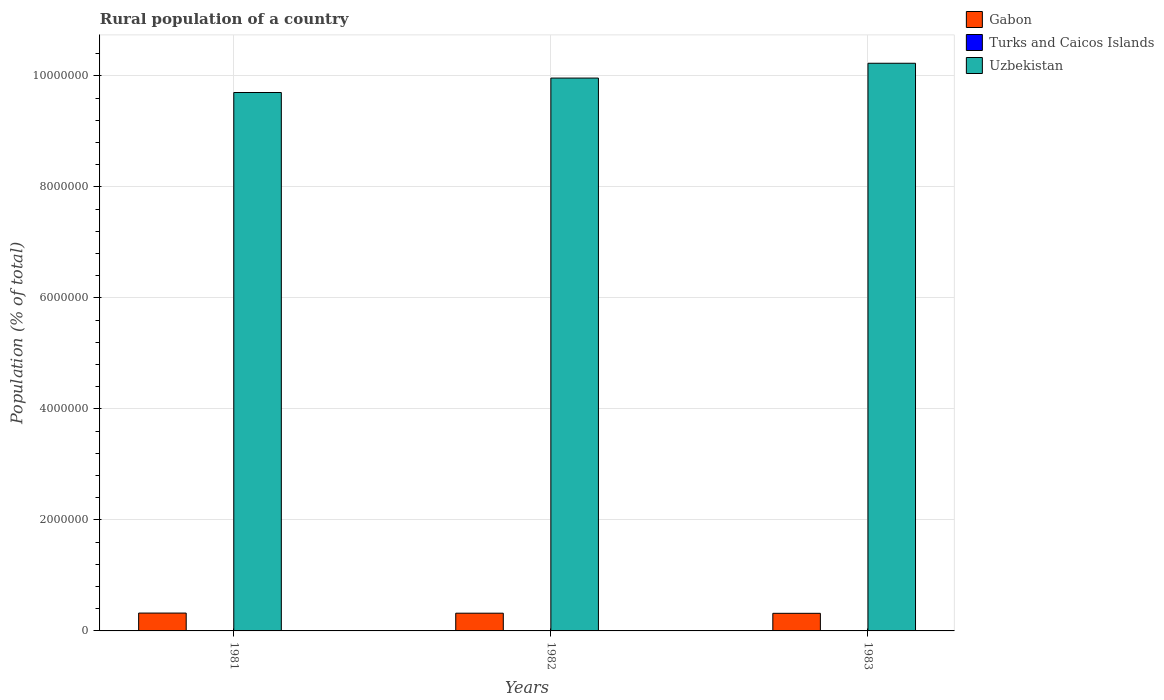How many groups of bars are there?
Offer a terse response. 3. Are the number of bars on each tick of the X-axis equal?
Offer a very short reply. Yes. How many bars are there on the 3rd tick from the right?
Ensure brevity in your answer.  3. What is the rural population in Turks and Caicos Islands in 1981?
Keep it short and to the point. 3350. Across all years, what is the maximum rural population in Uzbekistan?
Keep it short and to the point. 1.02e+07. Across all years, what is the minimum rural population in Gabon?
Make the answer very short. 3.17e+05. What is the total rural population in Gabon in the graph?
Your response must be concise. 9.58e+05. What is the difference between the rural population in Turks and Caicos Islands in 1981 and that in 1982?
Offer a very short reply. 5. What is the difference between the rural population in Uzbekistan in 1982 and the rural population in Gabon in 1983?
Make the answer very short. 9.64e+06. What is the average rural population in Turks and Caicos Islands per year?
Your answer should be very brief. 3345. In the year 1981, what is the difference between the rural population in Turks and Caicos Islands and rural population in Gabon?
Offer a terse response. -3.18e+05. What is the ratio of the rural population in Uzbekistan in 1981 to that in 1982?
Give a very brief answer. 0.97. Is the rural population in Uzbekistan in 1982 less than that in 1983?
Offer a very short reply. Yes. What is the difference between the highest and the second highest rural population in Uzbekistan?
Your answer should be compact. 2.67e+05. What is the difference between the highest and the lowest rural population in Uzbekistan?
Your answer should be very brief. 5.27e+05. What does the 3rd bar from the left in 1983 represents?
Your response must be concise. Uzbekistan. What does the 1st bar from the right in 1981 represents?
Your answer should be compact. Uzbekistan. Is it the case that in every year, the sum of the rural population in Gabon and rural population in Turks and Caicos Islands is greater than the rural population in Uzbekistan?
Your response must be concise. No. What is the difference between two consecutive major ticks on the Y-axis?
Provide a short and direct response. 2.00e+06. Are the values on the major ticks of Y-axis written in scientific E-notation?
Ensure brevity in your answer.  No. Does the graph contain any zero values?
Ensure brevity in your answer.  No. How are the legend labels stacked?
Ensure brevity in your answer.  Vertical. What is the title of the graph?
Ensure brevity in your answer.  Rural population of a country. Does "Puerto Rico" appear as one of the legend labels in the graph?
Offer a very short reply. No. What is the label or title of the Y-axis?
Give a very brief answer. Population (% of total). What is the Population (% of total) in Gabon in 1981?
Your answer should be very brief. 3.21e+05. What is the Population (% of total) in Turks and Caicos Islands in 1981?
Provide a succinct answer. 3350. What is the Population (% of total) in Uzbekistan in 1981?
Give a very brief answer. 9.70e+06. What is the Population (% of total) in Gabon in 1982?
Your answer should be very brief. 3.19e+05. What is the Population (% of total) in Turks and Caicos Islands in 1982?
Keep it short and to the point. 3345. What is the Population (% of total) in Uzbekistan in 1982?
Ensure brevity in your answer.  9.96e+06. What is the Population (% of total) in Gabon in 1983?
Offer a very short reply. 3.17e+05. What is the Population (% of total) of Turks and Caicos Islands in 1983?
Provide a succinct answer. 3340. What is the Population (% of total) of Uzbekistan in 1983?
Your answer should be very brief. 1.02e+07. Across all years, what is the maximum Population (% of total) of Gabon?
Offer a very short reply. 3.21e+05. Across all years, what is the maximum Population (% of total) of Turks and Caicos Islands?
Offer a terse response. 3350. Across all years, what is the maximum Population (% of total) in Uzbekistan?
Make the answer very short. 1.02e+07. Across all years, what is the minimum Population (% of total) of Gabon?
Your answer should be compact. 3.17e+05. Across all years, what is the minimum Population (% of total) of Turks and Caicos Islands?
Ensure brevity in your answer.  3340. Across all years, what is the minimum Population (% of total) in Uzbekistan?
Give a very brief answer. 9.70e+06. What is the total Population (% of total) of Gabon in the graph?
Offer a very short reply. 9.58e+05. What is the total Population (% of total) of Turks and Caicos Islands in the graph?
Your answer should be very brief. 1.00e+04. What is the total Population (% of total) of Uzbekistan in the graph?
Keep it short and to the point. 2.99e+07. What is the difference between the Population (% of total) of Gabon in 1981 and that in 1982?
Make the answer very short. 2234. What is the difference between the Population (% of total) of Uzbekistan in 1981 and that in 1982?
Ensure brevity in your answer.  -2.60e+05. What is the difference between the Population (% of total) in Gabon in 1981 and that in 1983?
Provide a short and direct response. 4533. What is the difference between the Population (% of total) in Turks and Caicos Islands in 1981 and that in 1983?
Keep it short and to the point. 10. What is the difference between the Population (% of total) of Uzbekistan in 1981 and that in 1983?
Give a very brief answer. -5.27e+05. What is the difference between the Population (% of total) in Gabon in 1982 and that in 1983?
Your answer should be compact. 2299. What is the difference between the Population (% of total) of Uzbekistan in 1982 and that in 1983?
Give a very brief answer. -2.67e+05. What is the difference between the Population (% of total) in Gabon in 1981 and the Population (% of total) in Turks and Caicos Islands in 1982?
Your answer should be very brief. 3.18e+05. What is the difference between the Population (% of total) in Gabon in 1981 and the Population (% of total) in Uzbekistan in 1982?
Your response must be concise. -9.64e+06. What is the difference between the Population (% of total) of Turks and Caicos Islands in 1981 and the Population (% of total) of Uzbekistan in 1982?
Provide a succinct answer. -9.96e+06. What is the difference between the Population (% of total) of Gabon in 1981 and the Population (% of total) of Turks and Caicos Islands in 1983?
Keep it short and to the point. 3.18e+05. What is the difference between the Population (% of total) of Gabon in 1981 and the Population (% of total) of Uzbekistan in 1983?
Offer a very short reply. -9.90e+06. What is the difference between the Population (% of total) in Turks and Caicos Islands in 1981 and the Population (% of total) in Uzbekistan in 1983?
Offer a terse response. -1.02e+07. What is the difference between the Population (% of total) in Gabon in 1982 and the Population (% of total) in Turks and Caicos Islands in 1983?
Your response must be concise. 3.16e+05. What is the difference between the Population (% of total) in Gabon in 1982 and the Population (% of total) in Uzbekistan in 1983?
Your response must be concise. -9.91e+06. What is the difference between the Population (% of total) in Turks and Caicos Islands in 1982 and the Population (% of total) in Uzbekistan in 1983?
Your answer should be very brief. -1.02e+07. What is the average Population (% of total) in Gabon per year?
Offer a terse response. 3.19e+05. What is the average Population (% of total) in Turks and Caicos Islands per year?
Keep it short and to the point. 3345. What is the average Population (% of total) in Uzbekistan per year?
Offer a terse response. 9.96e+06. In the year 1981, what is the difference between the Population (% of total) of Gabon and Population (% of total) of Turks and Caicos Islands?
Your response must be concise. 3.18e+05. In the year 1981, what is the difference between the Population (% of total) in Gabon and Population (% of total) in Uzbekistan?
Provide a succinct answer. -9.38e+06. In the year 1981, what is the difference between the Population (% of total) in Turks and Caicos Islands and Population (% of total) in Uzbekistan?
Offer a very short reply. -9.70e+06. In the year 1982, what is the difference between the Population (% of total) in Gabon and Population (% of total) in Turks and Caicos Islands?
Give a very brief answer. 3.16e+05. In the year 1982, what is the difference between the Population (% of total) in Gabon and Population (% of total) in Uzbekistan?
Your answer should be compact. -9.64e+06. In the year 1982, what is the difference between the Population (% of total) of Turks and Caicos Islands and Population (% of total) of Uzbekistan?
Your answer should be very brief. -9.96e+06. In the year 1983, what is the difference between the Population (% of total) of Gabon and Population (% of total) of Turks and Caicos Islands?
Your response must be concise. 3.14e+05. In the year 1983, what is the difference between the Population (% of total) in Gabon and Population (% of total) in Uzbekistan?
Keep it short and to the point. -9.91e+06. In the year 1983, what is the difference between the Population (% of total) in Turks and Caicos Islands and Population (% of total) in Uzbekistan?
Keep it short and to the point. -1.02e+07. What is the ratio of the Population (% of total) in Turks and Caicos Islands in 1981 to that in 1982?
Your answer should be compact. 1. What is the ratio of the Population (% of total) of Uzbekistan in 1981 to that in 1982?
Keep it short and to the point. 0.97. What is the ratio of the Population (% of total) in Gabon in 1981 to that in 1983?
Give a very brief answer. 1.01. What is the ratio of the Population (% of total) of Uzbekistan in 1981 to that in 1983?
Make the answer very short. 0.95. What is the ratio of the Population (% of total) of Gabon in 1982 to that in 1983?
Ensure brevity in your answer.  1.01. What is the ratio of the Population (% of total) of Uzbekistan in 1982 to that in 1983?
Offer a terse response. 0.97. What is the difference between the highest and the second highest Population (% of total) in Gabon?
Offer a very short reply. 2234. What is the difference between the highest and the second highest Population (% of total) in Turks and Caicos Islands?
Offer a terse response. 5. What is the difference between the highest and the second highest Population (% of total) of Uzbekistan?
Ensure brevity in your answer.  2.67e+05. What is the difference between the highest and the lowest Population (% of total) of Gabon?
Keep it short and to the point. 4533. What is the difference between the highest and the lowest Population (% of total) in Turks and Caicos Islands?
Provide a succinct answer. 10. What is the difference between the highest and the lowest Population (% of total) of Uzbekistan?
Your response must be concise. 5.27e+05. 